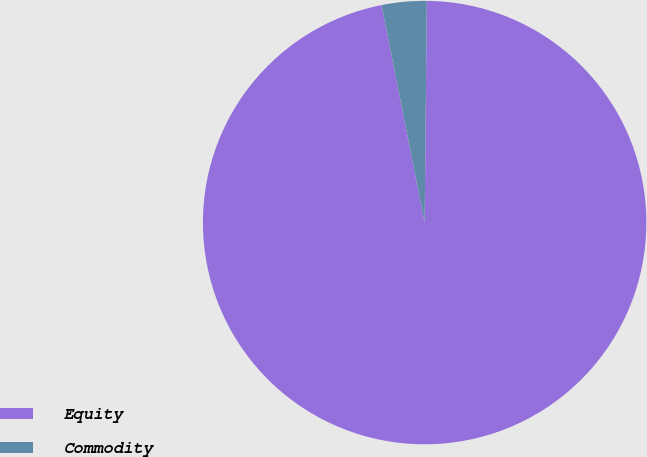<chart> <loc_0><loc_0><loc_500><loc_500><pie_chart><fcel>Equity<fcel>Commodity<nl><fcel>96.73%<fcel>3.27%<nl></chart> 